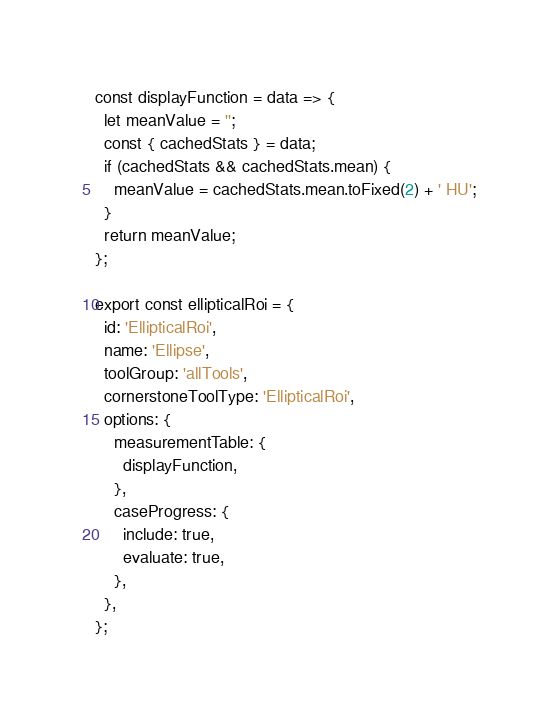<code> <loc_0><loc_0><loc_500><loc_500><_JavaScript_>const displayFunction = data => {
  let meanValue = '';
  const { cachedStats } = data;
  if (cachedStats && cachedStats.mean) {
    meanValue = cachedStats.mean.toFixed(2) + ' HU';
  }
  return meanValue;
};

export const ellipticalRoi = {
  id: 'EllipticalRoi',
  name: 'Ellipse',
  toolGroup: 'allTools',
  cornerstoneToolType: 'EllipticalRoi',
  options: {
    measurementTable: {
      displayFunction,
    },
    caseProgress: {
      include: true,
      evaluate: true,
    },
  },
};
</code> 